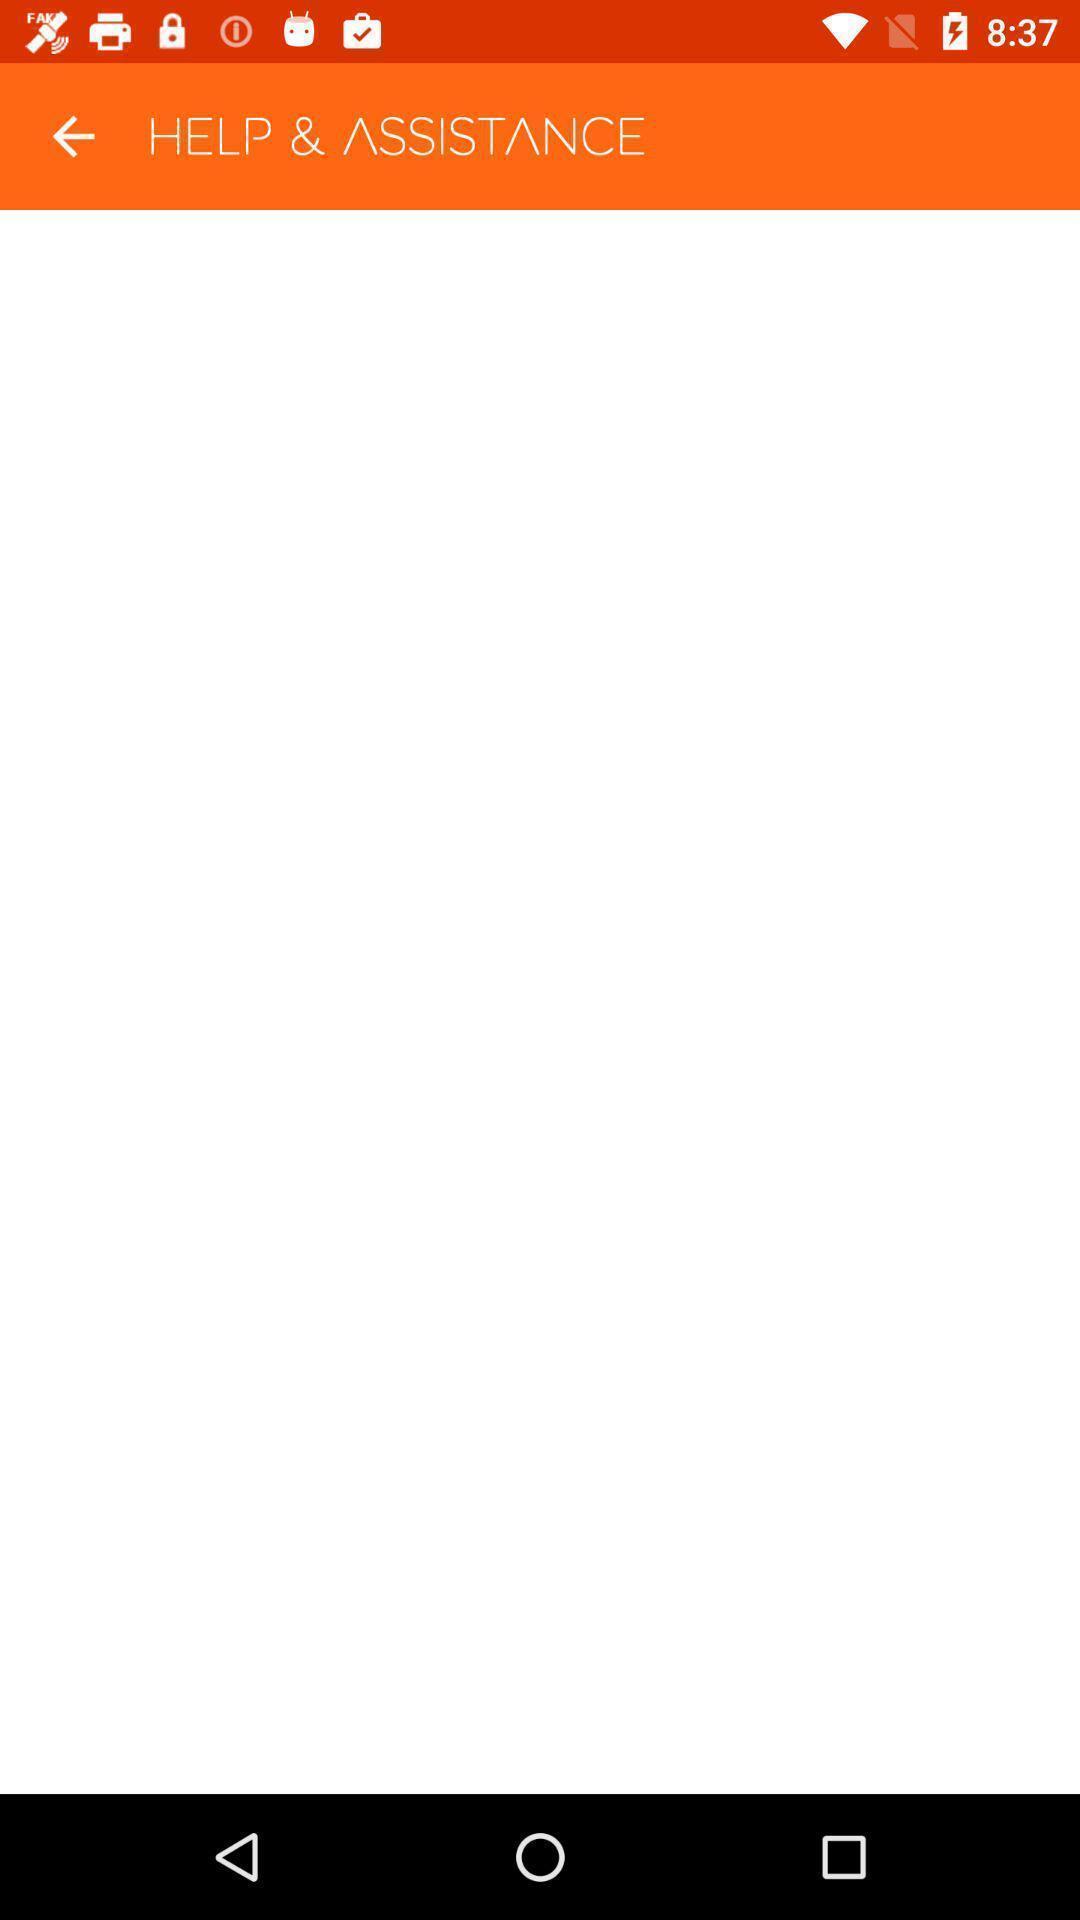Give me a summary of this screen capture. Screen shows about help and assistance. 